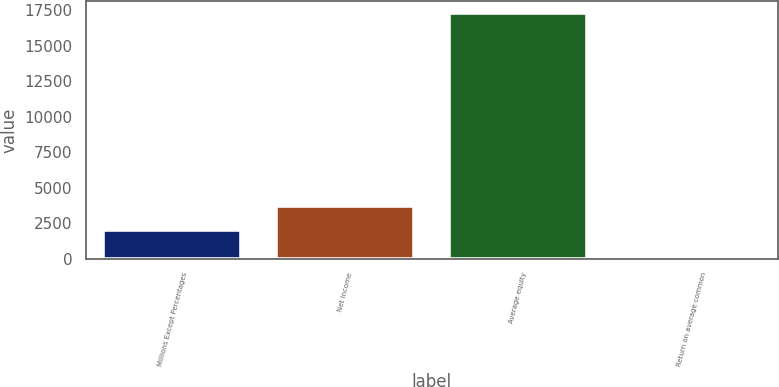Convert chart. <chart><loc_0><loc_0><loc_500><loc_500><bar_chart><fcel>Millions Except Percentages<fcel>Net income<fcel>Average equity<fcel>Return on average common<nl><fcel>2010<fcel>3736.59<fcel>17282<fcel>16.1<nl></chart> 